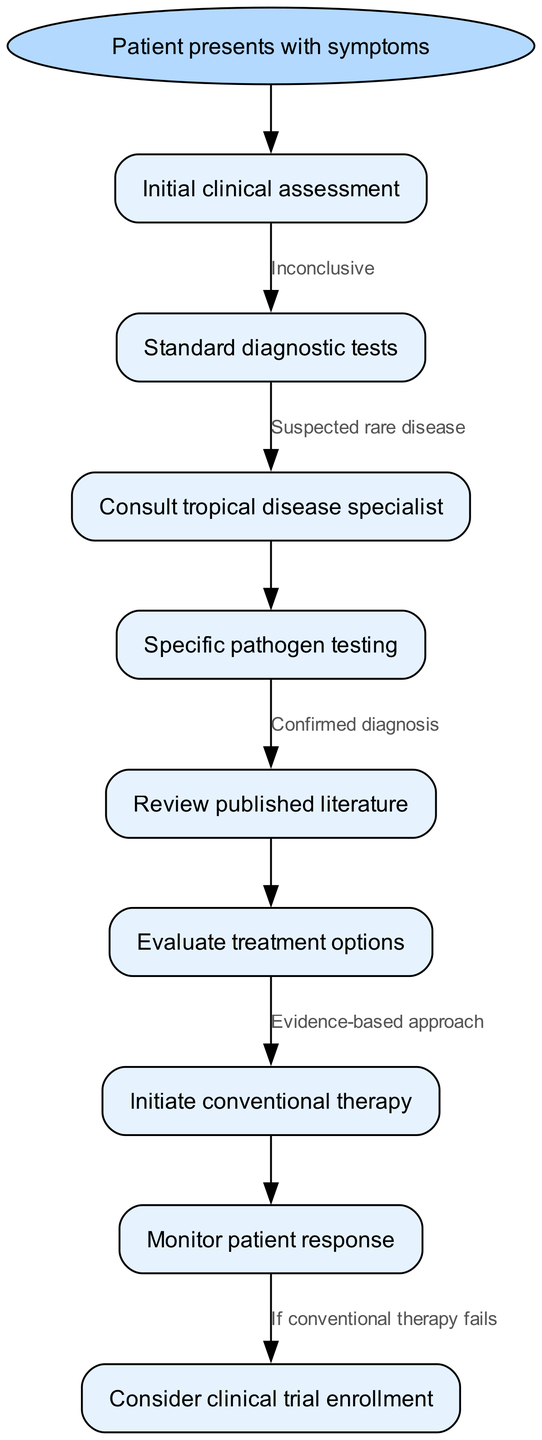What is the first step in the patient diagnosis pathway? The flowchart starts with the node "Patient presents with symptoms," which leads to the initial step of "Initial clinical assessment."
Answer: Initial clinical assessment How many nodes are there in the diagram? The diagram lists a total of 9 nodes, covering various aspects of the patient diagnosis and treatment pathway.
Answer: 9 What is the relationship between "Standard diagnostic tests" and "Consult tropical disease specialist"? "Standard diagnostic tests" leads to "Consult tropical disease specialist" based on the edge that connects these two nodes, which occurs if the tests suggest a suspected rare disease.
Answer: Suspected rare disease Which step follows "Specific pathogen testing"? After "Specific pathogen testing," the next step indicated in the diagram is "Review published literature."
Answer: Review published literature What action is taken if conventional therapy fails? If conventional therapy fails, the diagram suggests considering "clinical trial enrollment" as the next step in management.
Answer: Consider clinical trial enrollment Which node indicates evidence-based approach for treatment? The node "Evaluate treatment options" indicates that the approach will be based on existing evidence before proceeding to "Initiate conventional therapy."
Answer: Evidence-based approach What is the last step after monitoring patient response? The final action after "Monitor patient response" in the diagram is to consider "clinical trial enrollment" if conventional therapy has not been effective.
Answer: Consider clinical trial enrollment What is the outcome of the node if the initial assessment is "Inconclusive"? If the initial clinical assessment is "Inconclusive," it directs to the next step, which is conducting "Standard diagnostic tests."
Answer: Standard diagnostic tests Which node indicates a need for specialist consultation? The node that indicates the need for consulting a specialist is "Consult tropical disease specialist," which follows the "Standard diagnostic tests."
Answer: Consult tropical disease specialist 